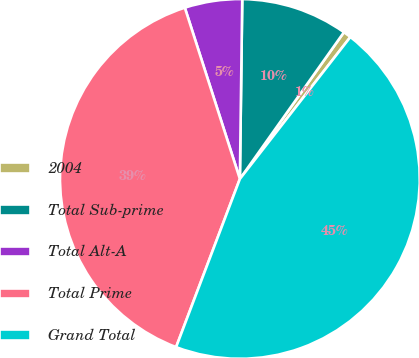Convert chart. <chart><loc_0><loc_0><loc_500><loc_500><pie_chart><fcel>2004<fcel>Total Sub-prime<fcel>Total Alt-A<fcel>Total Prime<fcel>Grand Total<nl><fcel>0.71%<fcel>9.61%<fcel>5.16%<fcel>39.28%<fcel>45.24%<nl></chart> 